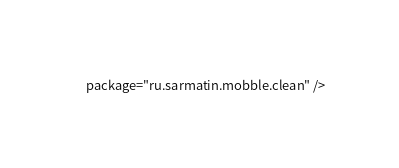Convert code to text. <code><loc_0><loc_0><loc_500><loc_500><_XML_>    package="ru.sarmatin.mobble.clean" />
</code> 